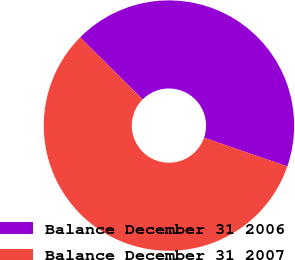<chart> <loc_0><loc_0><loc_500><loc_500><pie_chart><fcel>Balance December 31 2006<fcel>Balance December 31 2007<nl><fcel>42.84%<fcel>57.16%<nl></chart> 